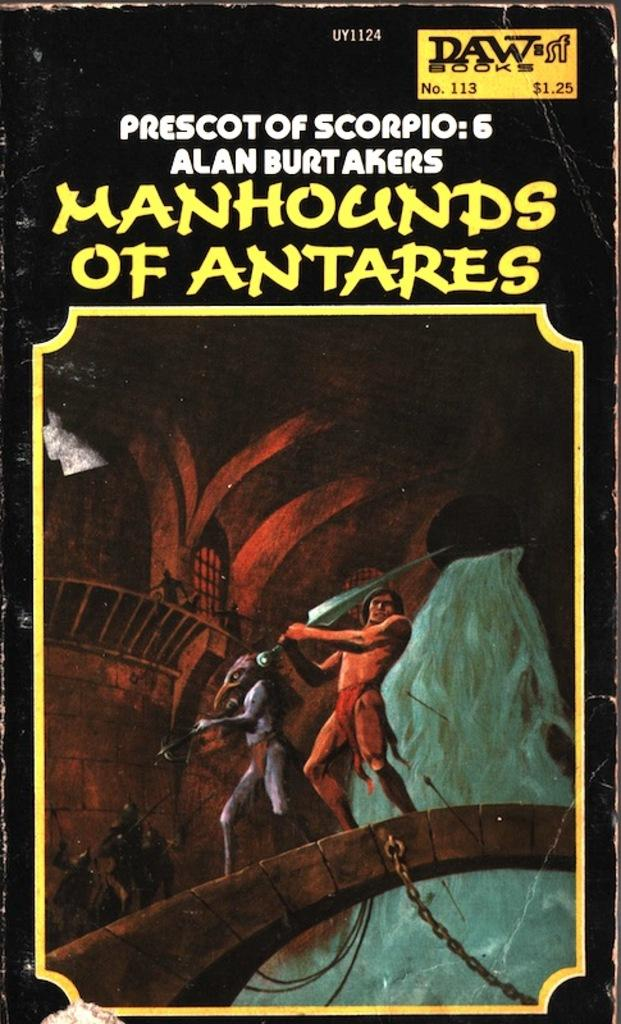<image>
Render a clear and concise summary of the photo. A book that is titled Manhounds of Antares 